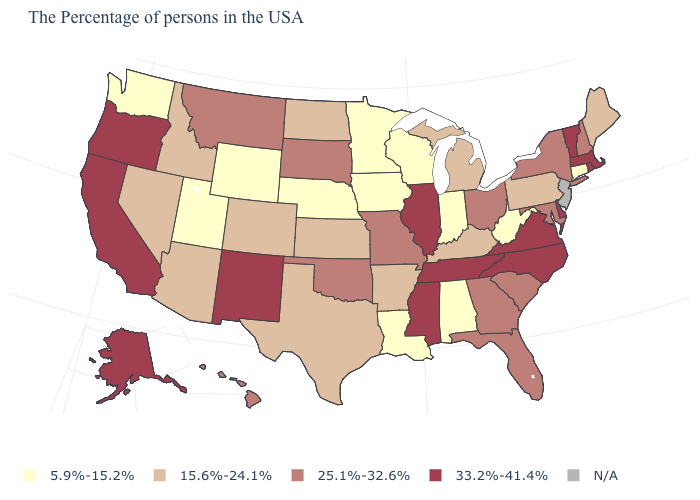Is the legend a continuous bar?
Give a very brief answer. No. What is the value of Arizona?
Be succinct. 15.6%-24.1%. What is the value of New York?
Give a very brief answer. 25.1%-32.6%. How many symbols are there in the legend?
Quick response, please. 5. What is the value of Louisiana?
Concise answer only. 5.9%-15.2%. What is the value of Washington?
Answer briefly. 5.9%-15.2%. What is the lowest value in states that border Vermont?
Write a very short answer. 25.1%-32.6%. What is the lowest value in states that border Minnesota?
Give a very brief answer. 5.9%-15.2%. Is the legend a continuous bar?
Answer briefly. No. Among the states that border California , which have the highest value?
Be succinct. Oregon. Name the states that have a value in the range 33.2%-41.4%?
Short answer required. Massachusetts, Rhode Island, Vermont, Delaware, Virginia, North Carolina, Tennessee, Illinois, Mississippi, New Mexico, California, Oregon, Alaska. How many symbols are there in the legend?
Write a very short answer. 5. Among the states that border Oklahoma , which have the lowest value?
Answer briefly. Arkansas, Kansas, Texas, Colorado. Among the states that border New Hampshire , does Maine have the highest value?
Keep it brief. No. 